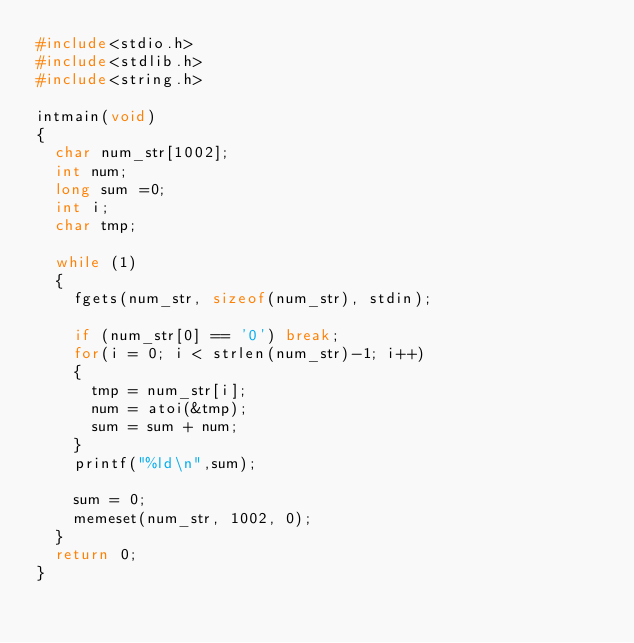Convert code to text. <code><loc_0><loc_0><loc_500><loc_500><_C_>#include<stdio.h>
#include<stdlib.h>
#include<string.h>

intmain(void)
{
	char num_str[1002];
	int num;
	long sum =0;
	int i;
	char tmp;
	
	while (1)
	{
		fgets(num_str, sizeof(num_str), stdin);
		
		if (num_str[0] == '0') break;
		for(i = 0; i < strlen(num_str)-1; i++)
		{
			tmp = num_str[i];
			num = atoi(&tmp);
			sum = sum + num;
		}
		printf("%ld\n",sum);
		
		sum = 0;
		memeset(num_str, 1002, 0);
	}
	return 0;
}</code> 